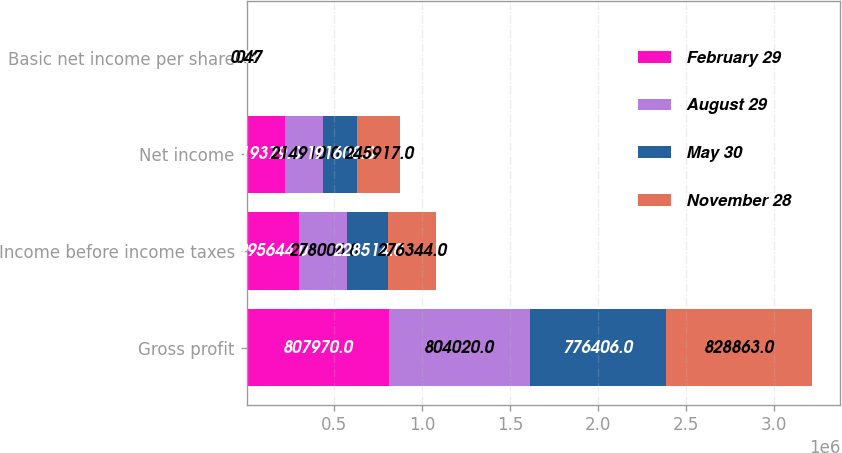Convert chart. <chart><loc_0><loc_0><loc_500><loc_500><stacked_bar_chart><ecel><fcel>Gross profit<fcel>Income before income taxes<fcel>Net income<fcel>Basic net income per share<nl><fcel>February 29<fcel>807970<fcel>295644<fcel>219379<fcel>0.39<nl><fcel>August 29<fcel>804020<fcel>278006<fcel>214910<fcel>0.4<nl><fcel>May 30<fcel>776406<fcel>228514<fcel>191608<fcel>0.36<nl><fcel>November 28<fcel>828863<fcel>276344<fcel>245917<fcel>0.47<nl></chart> 